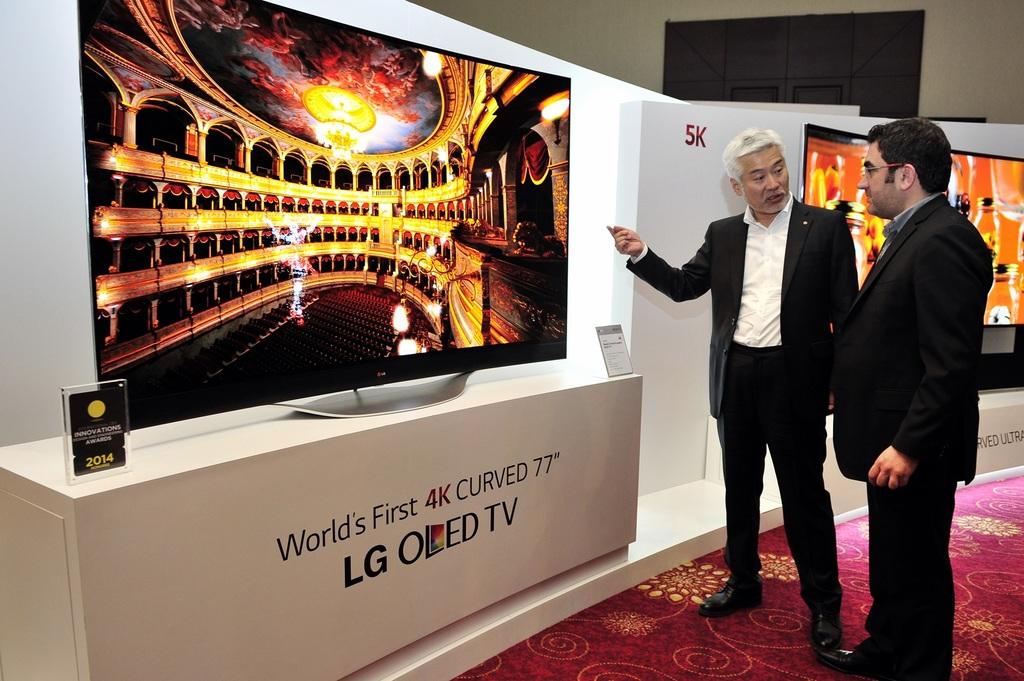What brand tv is this?
Your answer should be compact. Lg. 